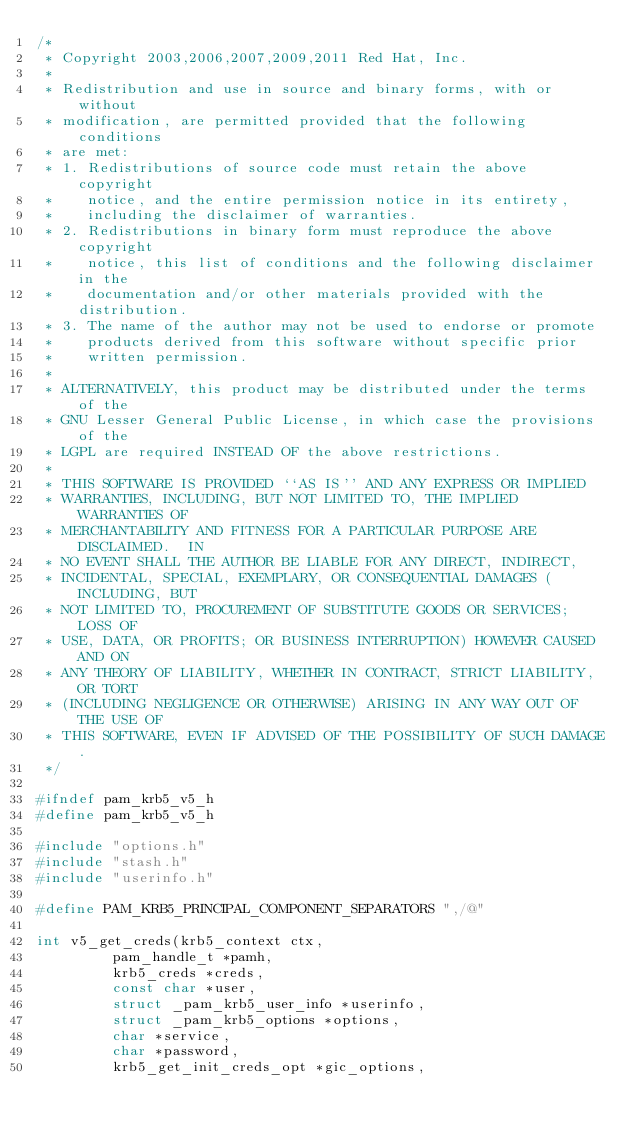Convert code to text. <code><loc_0><loc_0><loc_500><loc_500><_C_>/*
 * Copyright 2003,2006,2007,2009,2011 Red Hat, Inc.
 *
 * Redistribution and use in source and binary forms, with or without
 * modification, are permitted provided that the following conditions
 * are met:
 * 1. Redistributions of source code must retain the above copyright
 *    notice, and the entire permission notice in its entirety,
 *    including the disclaimer of warranties.
 * 2. Redistributions in binary form must reproduce the above copyright
 *    notice, this list of conditions and the following disclaimer in the
 *    documentation and/or other materials provided with the distribution.
 * 3. The name of the author may not be used to endorse or promote
 *    products derived from this software without specific prior
 *    written permission.
 *
 * ALTERNATIVELY, this product may be distributed under the terms of the
 * GNU Lesser General Public License, in which case the provisions of the
 * LGPL are required INSTEAD OF the above restrictions.
 *
 * THIS SOFTWARE IS PROVIDED ``AS IS'' AND ANY EXPRESS OR IMPLIED
 * WARRANTIES, INCLUDING, BUT NOT LIMITED TO, THE IMPLIED WARRANTIES OF
 * MERCHANTABILITY AND FITNESS FOR A PARTICULAR PURPOSE ARE DISCLAIMED.  IN
 * NO EVENT SHALL THE AUTHOR BE LIABLE FOR ANY DIRECT, INDIRECT,
 * INCIDENTAL, SPECIAL, EXEMPLARY, OR CONSEQUENTIAL DAMAGES (INCLUDING, BUT
 * NOT LIMITED TO, PROCUREMENT OF SUBSTITUTE GOODS OR SERVICES; LOSS OF
 * USE, DATA, OR PROFITS; OR BUSINESS INTERRUPTION) HOWEVER CAUSED AND ON
 * ANY THEORY OF LIABILITY, WHETHER IN CONTRACT, STRICT LIABILITY, OR TORT
 * (INCLUDING NEGLIGENCE OR OTHERWISE) ARISING IN ANY WAY OUT OF THE USE OF
 * THIS SOFTWARE, EVEN IF ADVISED OF THE POSSIBILITY OF SUCH DAMAGE.
 */

#ifndef pam_krb5_v5_h
#define pam_krb5_v5_h

#include "options.h"
#include "stash.h"
#include "userinfo.h"

#define PAM_KRB5_PRINCIPAL_COMPONENT_SEPARATORS ",/@"

int v5_get_creds(krb5_context ctx,
		 pam_handle_t *pamh,
		 krb5_creds *creds,
		 const char *user,
		 struct _pam_krb5_user_info *userinfo,
		 struct _pam_krb5_options *options,
		 char *service,
		 char *password,
		 krb5_get_init_creds_opt *gic_options,</code> 